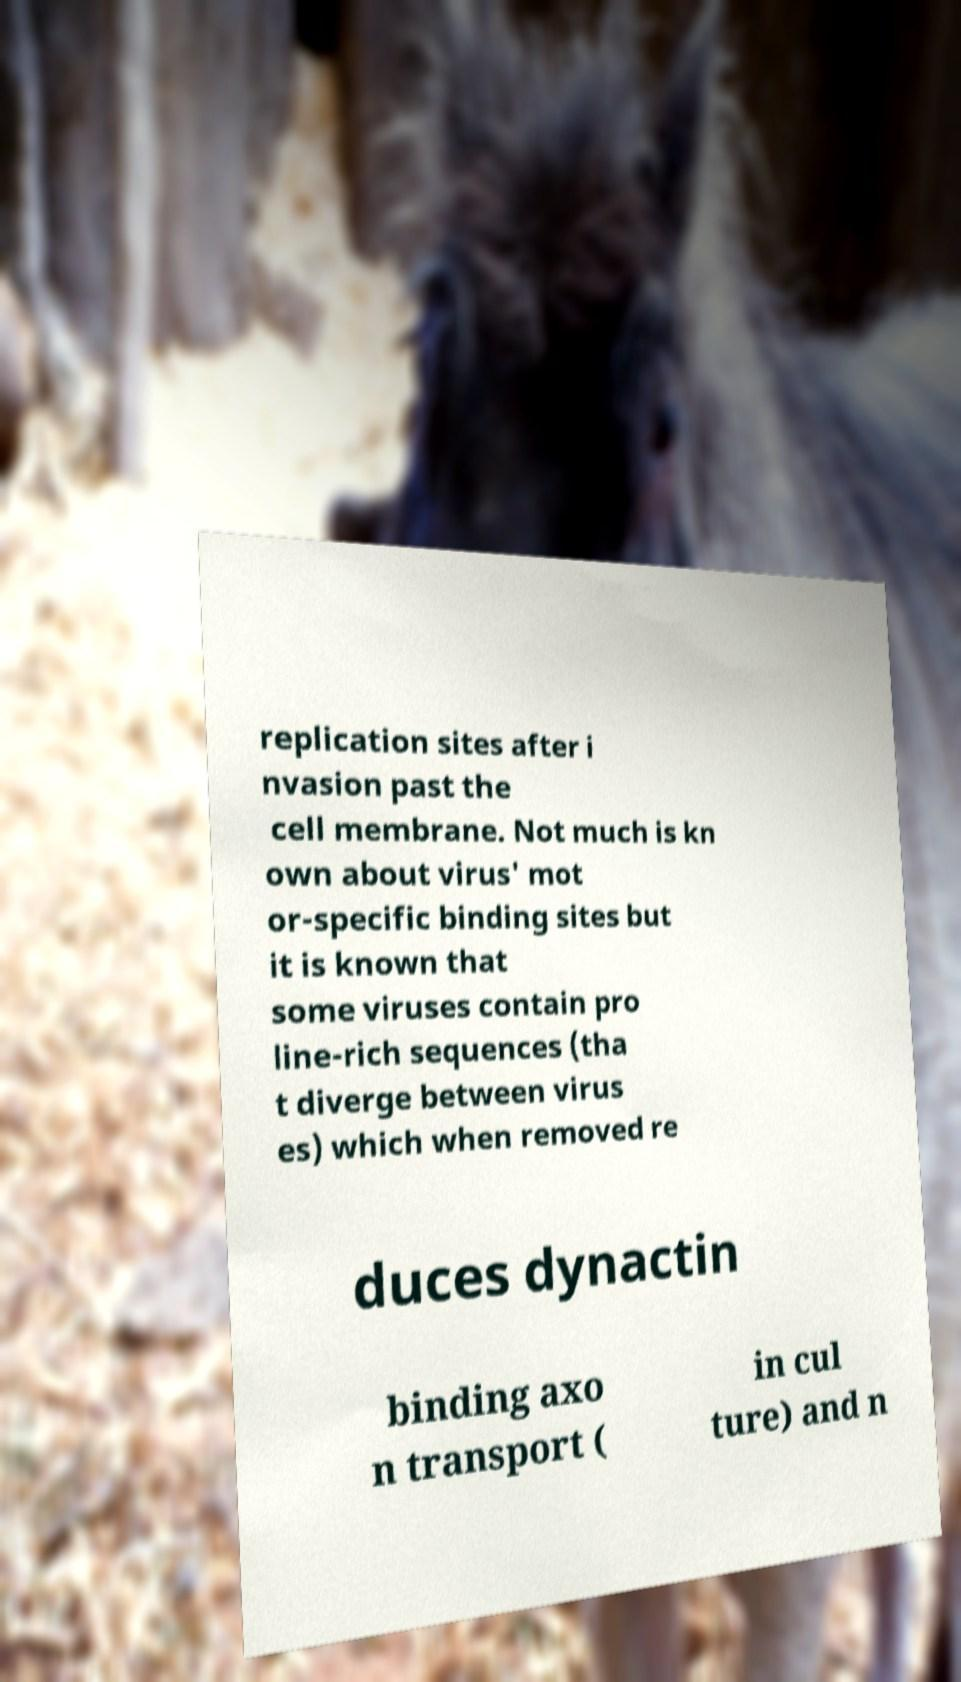For documentation purposes, I need the text within this image transcribed. Could you provide that? replication sites after i nvasion past the cell membrane. Not much is kn own about virus' mot or-specific binding sites but it is known that some viruses contain pro line-rich sequences (tha t diverge between virus es) which when removed re duces dynactin binding axo n transport ( in cul ture) and n 